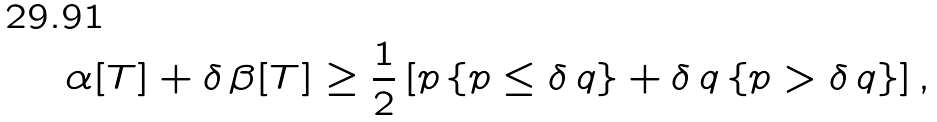<formula> <loc_0><loc_0><loc_500><loc_500>\alpha [ T ] + \delta \, \beta [ T ] \geq \frac { 1 } { 2 } \left [ p \left \{ p \leq \delta \, q \right \} + \delta \, q \left \{ p > \delta \, q \right \} \right ] ,</formula> 